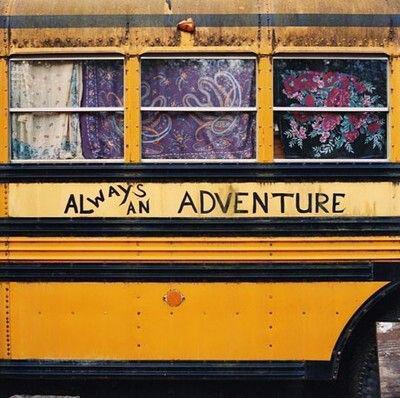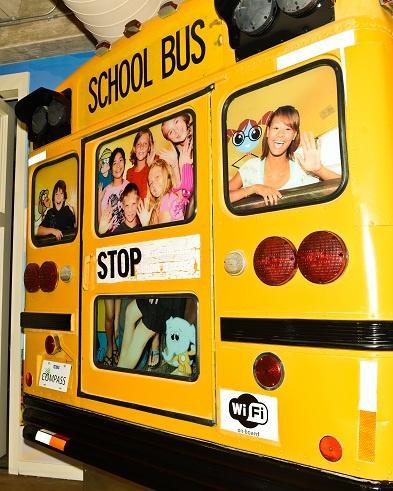The first image is the image on the left, the second image is the image on the right. Examine the images to the left and right. Is the description "In one of the images, there is a person standing outside of the bus." accurate? Answer yes or no. No. The first image is the image on the left, the second image is the image on the right. Considering the images on both sides, is "In the right image, childrens' heads are peering out of the top half of open bus windows, and at least one hand is gripping a window ledge." valid? Answer yes or no. No. 